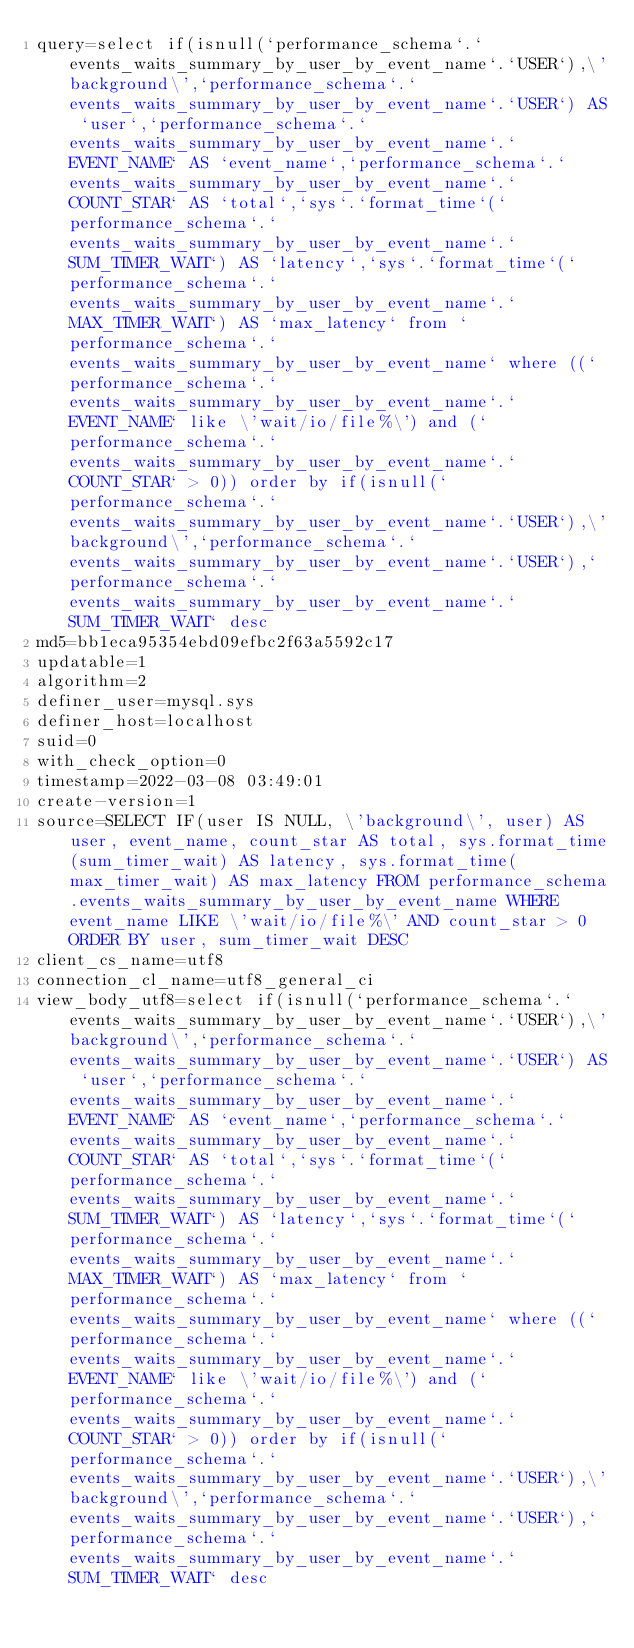Convert code to text. <code><loc_0><loc_0><loc_500><loc_500><_VisualBasic_>query=select if(isnull(`performance_schema`.`events_waits_summary_by_user_by_event_name`.`USER`),\'background\',`performance_schema`.`events_waits_summary_by_user_by_event_name`.`USER`) AS `user`,`performance_schema`.`events_waits_summary_by_user_by_event_name`.`EVENT_NAME` AS `event_name`,`performance_schema`.`events_waits_summary_by_user_by_event_name`.`COUNT_STAR` AS `total`,`sys`.`format_time`(`performance_schema`.`events_waits_summary_by_user_by_event_name`.`SUM_TIMER_WAIT`) AS `latency`,`sys`.`format_time`(`performance_schema`.`events_waits_summary_by_user_by_event_name`.`MAX_TIMER_WAIT`) AS `max_latency` from `performance_schema`.`events_waits_summary_by_user_by_event_name` where ((`performance_schema`.`events_waits_summary_by_user_by_event_name`.`EVENT_NAME` like \'wait/io/file%\') and (`performance_schema`.`events_waits_summary_by_user_by_event_name`.`COUNT_STAR` > 0)) order by if(isnull(`performance_schema`.`events_waits_summary_by_user_by_event_name`.`USER`),\'background\',`performance_schema`.`events_waits_summary_by_user_by_event_name`.`USER`),`performance_schema`.`events_waits_summary_by_user_by_event_name`.`SUM_TIMER_WAIT` desc
md5=bb1eca95354ebd09efbc2f63a5592c17
updatable=1
algorithm=2
definer_user=mysql.sys
definer_host=localhost
suid=0
with_check_option=0
timestamp=2022-03-08 03:49:01
create-version=1
source=SELECT IF(user IS NULL, \'background\', user) AS user, event_name, count_star AS total, sys.format_time(sum_timer_wait) AS latency, sys.format_time(max_timer_wait) AS max_latency FROM performance_schema.events_waits_summary_by_user_by_event_name WHERE event_name LIKE \'wait/io/file%\' AND count_star > 0 ORDER BY user, sum_timer_wait DESC
client_cs_name=utf8
connection_cl_name=utf8_general_ci
view_body_utf8=select if(isnull(`performance_schema`.`events_waits_summary_by_user_by_event_name`.`USER`),\'background\',`performance_schema`.`events_waits_summary_by_user_by_event_name`.`USER`) AS `user`,`performance_schema`.`events_waits_summary_by_user_by_event_name`.`EVENT_NAME` AS `event_name`,`performance_schema`.`events_waits_summary_by_user_by_event_name`.`COUNT_STAR` AS `total`,`sys`.`format_time`(`performance_schema`.`events_waits_summary_by_user_by_event_name`.`SUM_TIMER_WAIT`) AS `latency`,`sys`.`format_time`(`performance_schema`.`events_waits_summary_by_user_by_event_name`.`MAX_TIMER_WAIT`) AS `max_latency` from `performance_schema`.`events_waits_summary_by_user_by_event_name` where ((`performance_schema`.`events_waits_summary_by_user_by_event_name`.`EVENT_NAME` like \'wait/io/file%\') and (`performance_schema`.`events_waits_summary_by_user_by_event_name`.`COUNT_STAR` > 0)) order by if(isnull(`performance_schema`.`events_waits_summary_by_user_by_event_name`.`USER`),\'background\',`performance_schema`.`events_waits_summary_by_user_by_event_name`.`USER`),`performance_schema`.`events_waits_summary_by_user_by_event_name`.`SUM_TIMER_WAIT` desc
</code> 